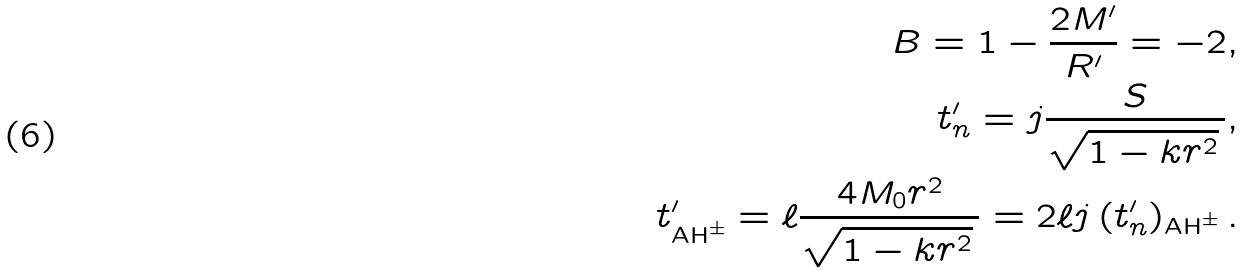<formula> <loc_0><loc_0><loc_500><loc_500>B = 1 - \frac { 2 M ^ { \prime } } { R ^ { \prime } } = - 2 , \\ t ^ { \prime } _ { n } = j \frac { S } { \sqrt { 1 - k r ^ { 2 } } \, } , \\ t ^ { \prime } _ { \text {AH} ^ { \pm } } = \ell \frac { 4 M _ { 0 } r ^ { 2 } } { \sqrt { 1 - k r ^ { 2 } } \, } = 2 \ell j \, ( t _ { n } ^ { \prime } ) _ { \text {AH} ^ { \pm } } \, .</formula> 